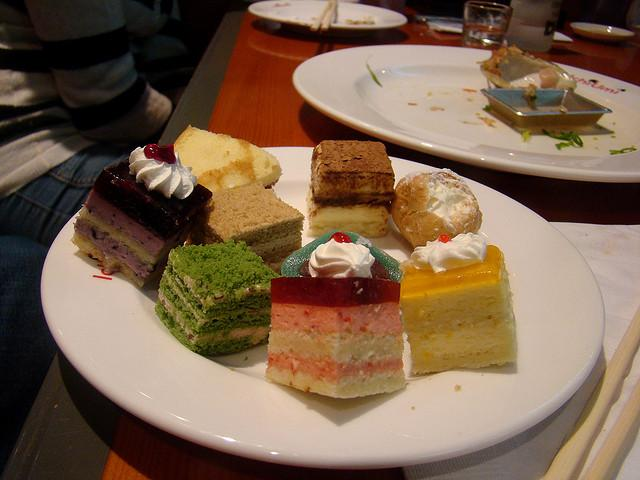What is the English translation of the French name for these? Please explain your reasoning. little oven. They are mini. 